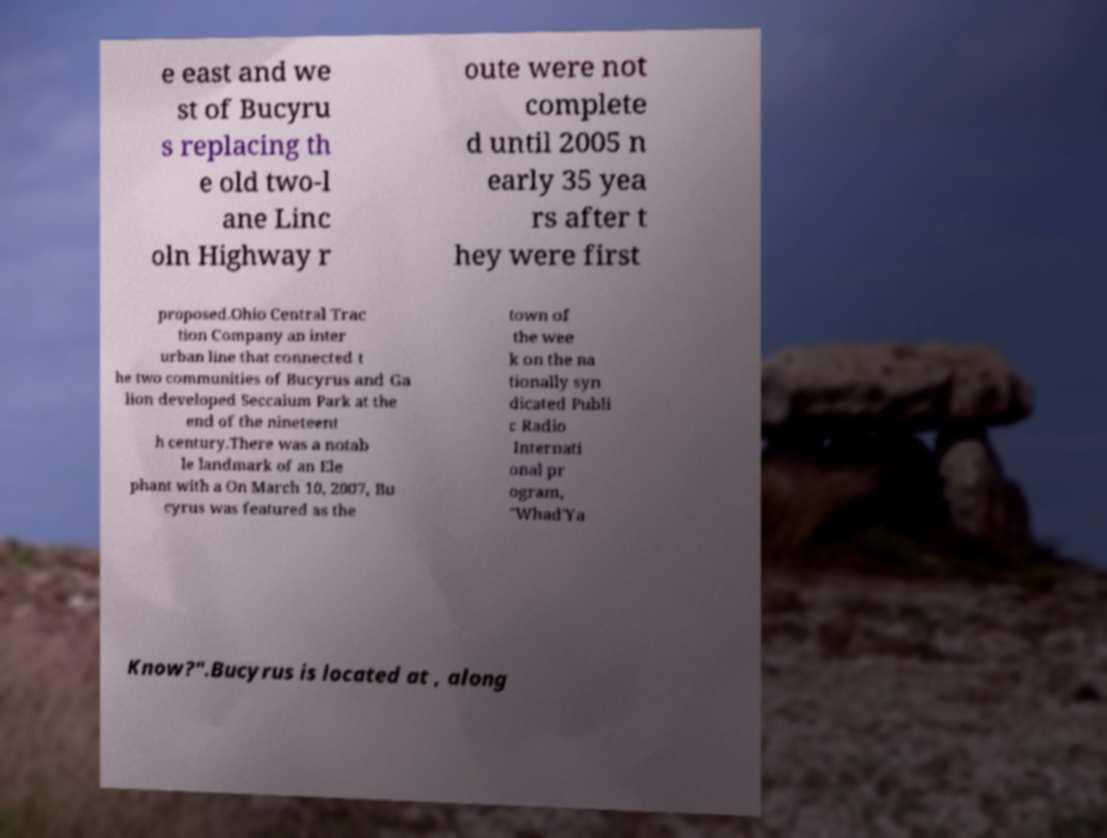Please read and relay the text visible in this image. What does it say? e east and we st of Bucyru s replacing th e old two-l ane Linc oln Highway r oute were not complete d until 2005 n early 35 yea rs after t hey were first proposed.Ohio Central Trac tion Company an inter urban line that connected t he two communities of Bucyrus and Ga lion developed Seccaium Park at the end of the nineteent h century.There was a notab le landmark of an Ele phant with a On March 10, 2007, Bu cyrus was featured as the town of the wee k on the na tionally syn dicated Publi c Radio Internati onal pr ogram, "Whad'Ya Know?".Bucyrus is located at , along 